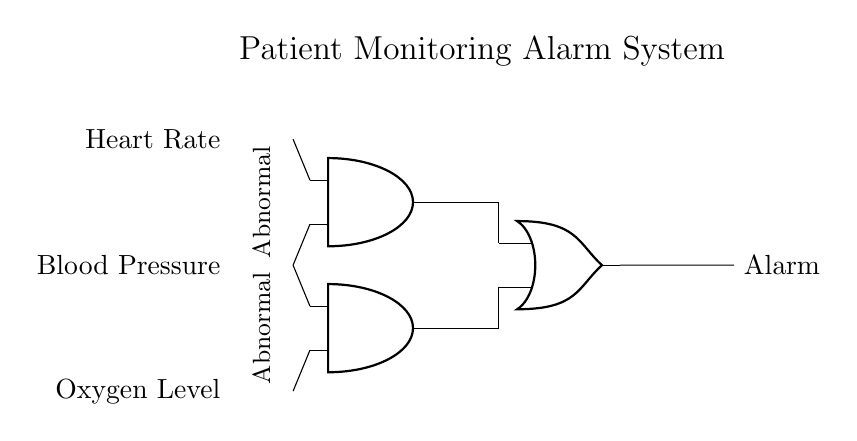What are the input sensors used in this circuit? The circuit has three input sensors: Heart Rate, Blood Pressure, and Oxygen Level. These sensors monitor the patient's vital signs.
Answer: Heart Rate, Blood Pressure, Oxygen Level How many AND gates are present in the diagram? There are two AND gates in the circuit, which are responsible for processing the signals from the input sensors.
Answer: Two What does the output of this circuit represent? The output of the circuit is defined as the Alarm, which indicates when patient monitoring parameters reach abnormal levels.
Answer: Alarm What connection type is used between AND gates and the OR gate? The connection type used is a non-inverting connection, where the output of the AND gates connects to the inputs of the OR gate in a way that can trigger the output if any condition is satisfied.
Answer: Non-inverting What kind of logic operation does the OR gate perform? The OR gate performs a logical disjunction, allowing the output to trigger the Alarm if at least one input condition from the AND gates is true (indicating an abnormal reading).
Answer: Logical disjunction What indicates an abnormal condition for the input sensors? Abnormal conditions are indicated by the labels "Abnormal" placed next to the Heart Rate and Blood Pressure sensors, which denote that these inputs are set to trigger the respective AND gate when they signify a problem.
Answer: Abnormal How many outputs does this circuit have? The circuit has a single output labeled "Alarm," which is the only result of the logical operations performed by the gates.
Answer: One 